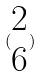Convert formula to latex. <formula><loc_0><loc_0><loc_500><loc_500>( \begin{matrix} 2 \\ 6 \end{matrix} )</formula> 